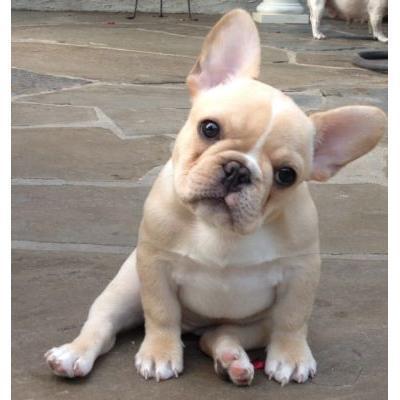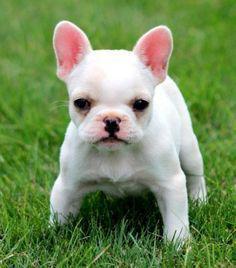The first image is the image on the left, the second image is the image on the right. For the images shown, is this caption "In one of the images a dog is wearing an object." true? Answer yes or no. No. The first image is the image on the left, the second image is the image on the right. Evaluate the accuracy of this statement regarding the images: "One dog has its tongue out.". Is it true? Answer yes or no. No. 